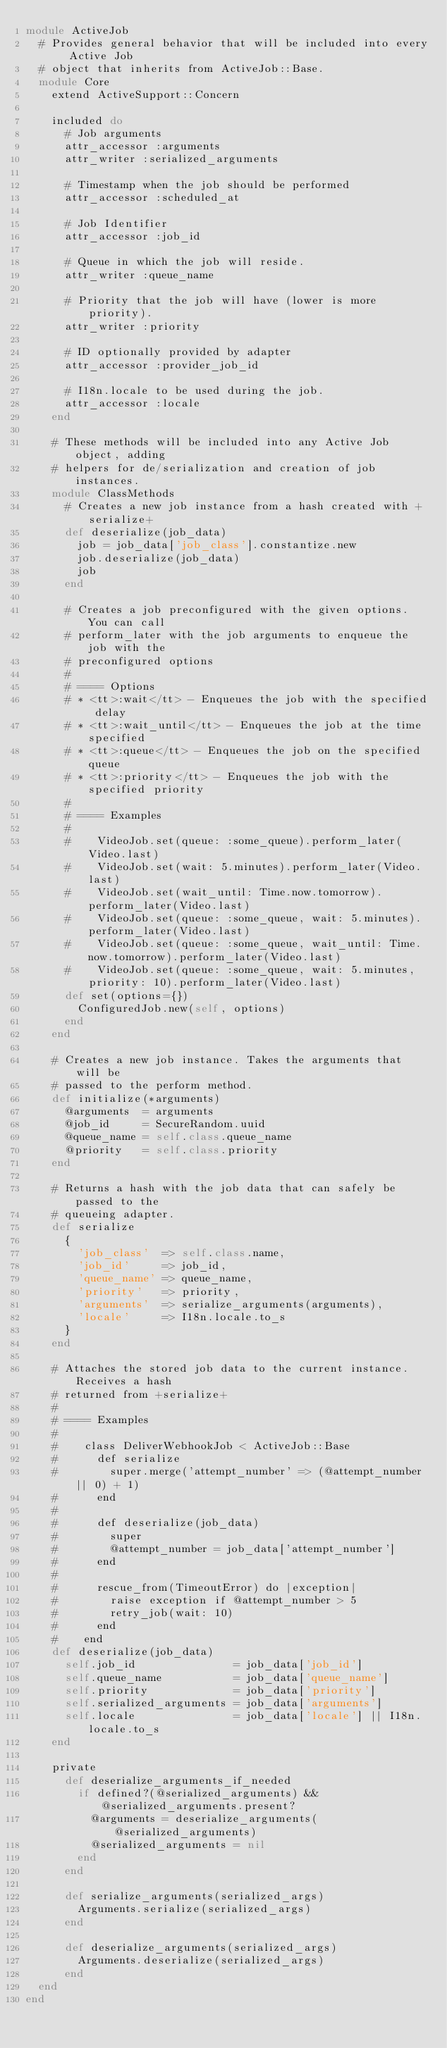Convert code to text. <code><loc_0><loc_0><loc_500><loc_500><_Ruby_>module ActiveJob
  # Provides general behavior that will be included into every Active Job
  # object that inherits from ActiveJob::Base.
  module Core
    extend ActiveSupport::Concern

    included do
      # Job arguments
      attr_accessor :arguments
      attr_writer :serialized_arguments

      # Timestamp when the job should be performed
      attr_accessor :scheduled_at

      # Job Identifier
      attr_accessor :job_id

      # Queue in which the job will reside.
      attr_writer :queue_name

      # Priority that the job will have (lower is more priority).
      attr_writer :priority

      # ID optionally provided by adapter
      attr_accessor :provider_job_id

      # I18n.locale to be used during the job.
      attr_accessor :locale
    end

    # These methods will be included into any Active Job object, adding
    # helpers for de/serialization and creation of job instances.
    module ClassMethods
      # Creates a new job instance from a hash created with +serialize+
      def deserialize(job_data)
        job = job_data['job_class'].constantize.new
        job.deserialize(job_data)
        job
      end

      # Creates a job preconfigured with the given options. You can call
      # perform_later with the job arguments to enqueue the job with the
      # preconfigured options
      #
      # ==== Options
      # * <tt>:wait</tt> - Enqueues the job with the specified delay
      # * <tt>:wait_until</tt> - Enqueues the job at the time specified
      # * <tt>:queue</tt> - Enqueues the job on the specified queue
      # * <tt>:priority</tt> - Enqueues the job with the specified priority
      #
      # ==== Examples
      #
      #    VideoJob.set(queue: :some_queue).perform_later(Video.last)
      #    VideoJob.set(wait: 5.minutes).perform_later(Video.last)
      #    VideoJob.set(wait_until: Time.now.tomorrow).perform_later(Video.last)
      #    VideoJob.set(queue: :some_queue, wait: 5.minutes).perform_later(Video.last)
      #    VideoJob.set(queue: :some_queue, wait_until: Time.now.tomorrow).perform_later(Video.last)
      #    VideoJob.set(queue: :some_queue, wait: 5.minutes, priority: 10).perform_later(Video.last)
      def set(options={})
        ConfiguredJob.new(self, options)
      end
    end

    # Creates a new job instance. Takes the arguments that will be
    # passed to the perform method.
    def initialize(*arguments)
      @arguments  = arguments
      @job_id     = SecureRandom.uuid
      @queue_name = self.class.queue_name
      @priority   = self.class.priority
    end

    # Returns a hash with the job data that can safely be passed to the
    # queueing adapter.
    def serialize
      {
        'job_class'  => self.class.name,
        'job_id'     => job_id,
        'queue_name' => queue_name,
        'priority'   => priority,
        'arguments'  => serialize_arguments(arguments),
        'locale'     => I18n.locale.to_s
      }
    end

    # Attaches the stored job data to the current instance. Receives a hash
    # returned from +serialize+
    #
    # ==== Examples
    #
    #    class DeliverWebhookJob < ActiveJob::Base
    #      def serialize
    #        super.merge('attempt_number' => (@attempt_number || 0) + 1)
    #      end
    #
    #      def deserialize(job_data)
    #        super
    #        @attempt_number = job_data['attempt_number']
    #      end
    #
    #      rescue_from(TimeoutError) do |exception|
    #        raise exception if @attempt_number > 5
    #        retry_job(wait: 10)
    #      end
    #    end
    def deserialize(job_data)
      self.job_id               = job_data['job_id']
      self.queue_name           = job_data['queue_name']
      self.priority             = job_data['priority']
      self.serialized_arguments = job_data['arguments']
      self.locale               = job_data['locale'] || I18n.locale.to_s
    end

    private
      def deserialize_arguments_if_needed
        if defined?(@serialized_arguments) && @serialized_arguments.present?
          @arguments = deserialize_arguments(@serialized_arguments)
          @serialized_arguments = nil
        end
      end

      def serialize_arguments(serialized_args)
        Arguments.serialize(serialized_args)
      end

      def deserialize_arguments(serialized_args)
        Arguments.deserialize(serialized_args)
      end
  end
end
</code> 